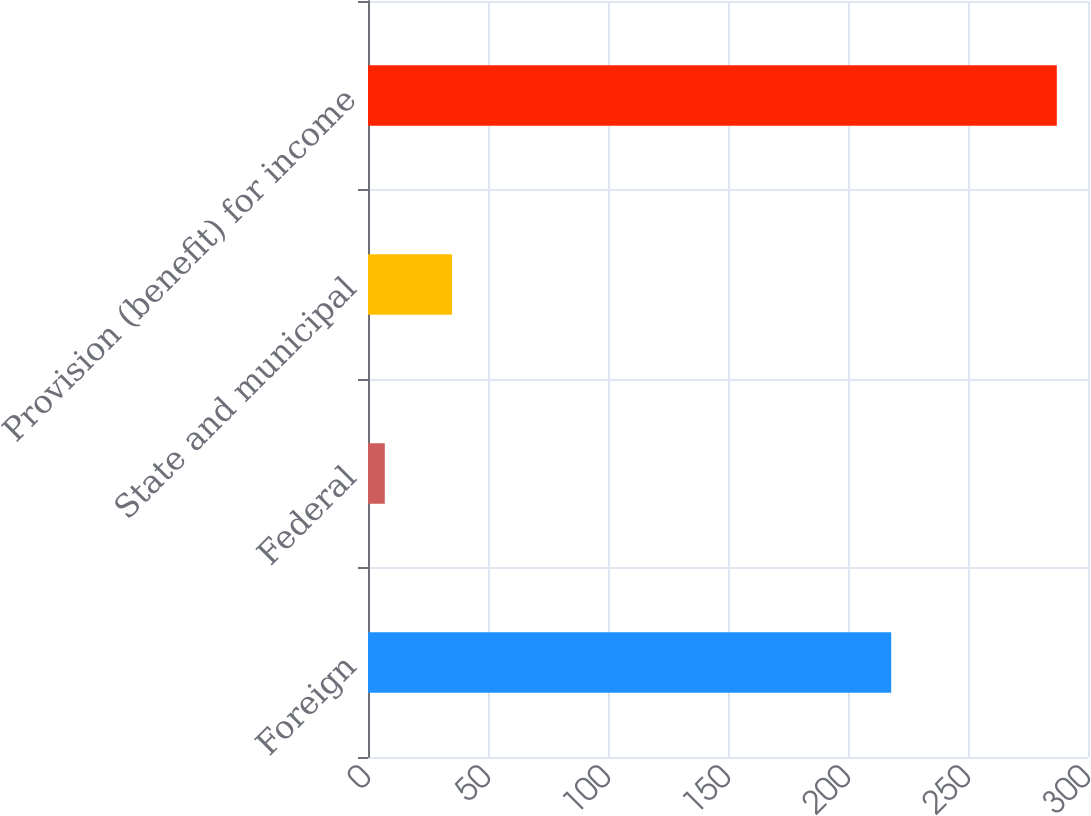Convert chart. <chart><loc_0><loc_0><loc_500><loc_500><bar_chart><fcel>Foreign<fcel>Federal<fcel>State and municipal<fcel>Provision (benefit) for income<nl><fcel>218<fcel>7<fcel>35<fcel>287<nl></chart> 